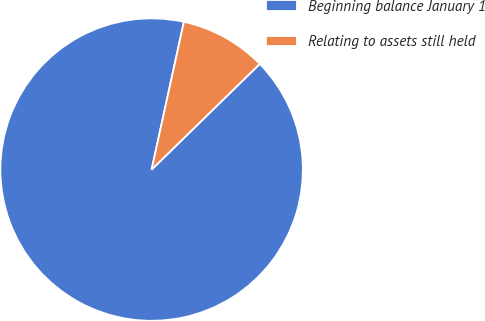Convert chart. <chart><loc_0><loc_0><loc_500><loc_500><pie_chart><fcel>Beginning balance January 1<fcel>Relating to assets still held<nl><fcel>90.74%<fcel>9.26%<nl></chart> 